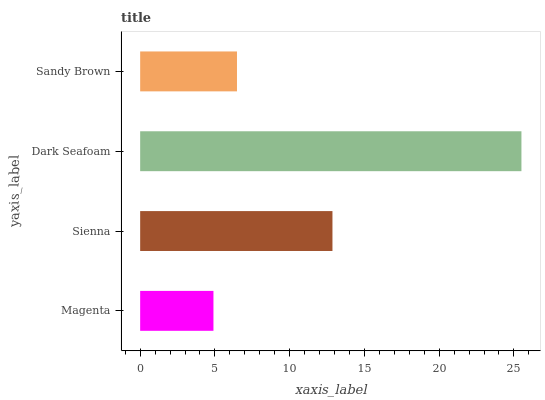Is Magenta the minimum?
Answer yes or no. Yes. Is Dark Seafoam the maximum?
Answer yes or no. Yes. Is Sienna the minimum?
Answer yes or no. No. Is Sienna the maximum?
Answer yes or no. No. Is Sienna greater than Magenta?
Answer yes or no. Yes. Is Magenta less than Sienna?
Answer yes or no. Yes. Is Magenta greater than Sienna?
Answer yes or no. No. Is Sienna less than Magenta?
Answer yes or no. No. Is Sienna the high median?
Answer yes or no. Yes. Is Sandy Brown the low median?
Answer yes or no. Yes. Is Magenta the high median?
Answer yes or no. No. Is Sienna the low median?
Answer yes or no. No. 